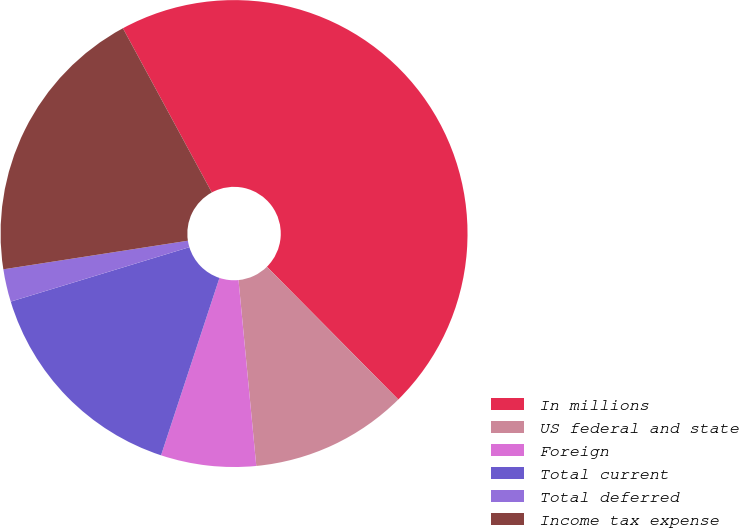Convert chart. <chart><loc_0><loc_0><loc_500><loc_500><pie_chart><fcel>In millions<fcel>US federal and state<fcel>Foreign<fcel>Total current<fcel>Total deferred<fcel>Income tax expense<nl><fcel>45.48%<fcel>10.9%<fcel>6.58%<fcel>15.23%<fcel>2.26%<fcel>19.55%<nl></chart> 